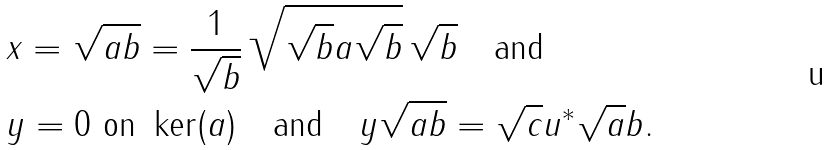Convert formula to latex. <formula><loc_0><loc_0><loc_500><loc_500>& x = \sqrt { a b } = \frac { 1 } { \sqrt { b } } \, \sqrt { \sqrt { b } a \sqrt { b } } \, \sqrt { b } \quad \text {and} \\ & y = 0 \text { on } \ker ( a ) \quad \text {and} \quad y \sqrt { a b } = \sqrt { c } u ^ { * } \sqrt { a } b .</formula> 